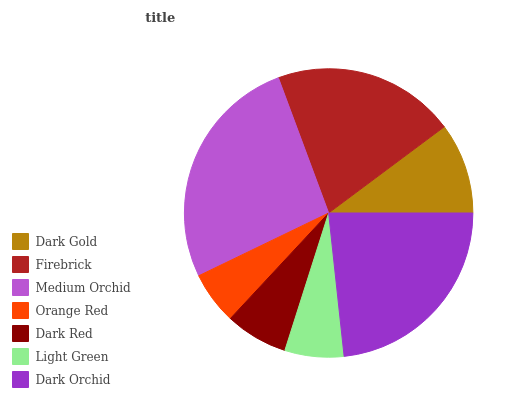Is Orange Red the minimum?
Answer yes or no. Yes. Is Medium Orchid the maximum?
Answer yes or no. Yes. Is Firebrick the minimum?
Answer yes or no. No. Is Firebrick the maximum?
Answer yes or no. No. Is Firebrick greater than Dark Gold?
Answer yes or no. Yes. Is Dark Gold less than Firebrick?
Answer yes or no. Yes. Is Dark Gold greater than Firebrick?
Answer yes or no. No. Is Firebrick less than Dark Gold?
Answer yes or no. No. Is Dark Gold the high median?
Answer yes or no. Yes. Is Dark Gold the low median?
Answer yes or no. Yes. Is Dark Orchid the high median?
Answer yes or no. No. Is Dark Red the low median?
Answer yes or no. No. 